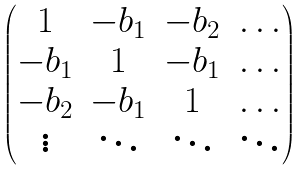Convert formula to latex. <formula><loc_0><loc_0><loc_500><loc_500>\begin{pmatrix} 1 & - b _ { 1 } & - b _ { 2 } & \dots \\ - b _ { 1 } & 1 & - b _ { 1 } & \dots \\ - b _ { 2 } & - b _ { 1 } & 1 & \dots \\ \vdots & \ddots & \ddots & \ddots \end{pmatrix}</formula> 